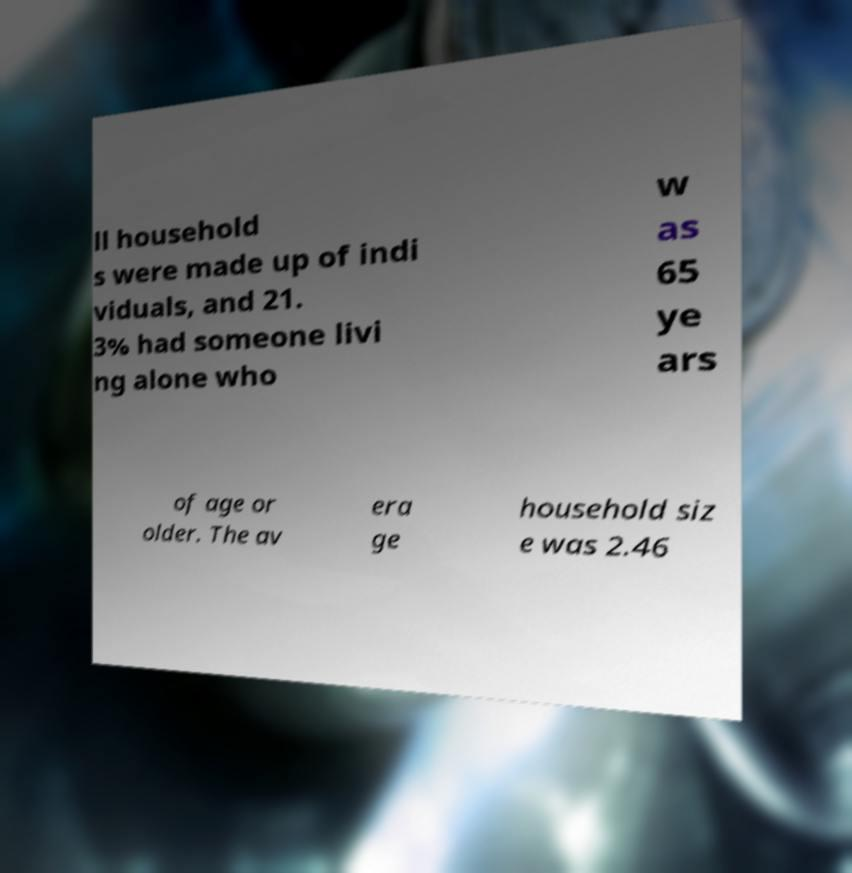There's text embedded in this image that I need extracted. Can you transcribe it verbatim? ll household s were made up of indi viduals, and 21. 3% had someone livi ng alone who w as 65 ye ars of age or older. The av era ge household siz e was 2.46 